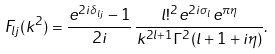<formula> <loc_0><loc_0><loc_500><loc_500>F _ { l j } ( k ^ { 2 } ) = \frac { e ^ { 2 i \delta _ { l j } } - 1 } { 2 i } \, \frac { l ! ^ { 2 } e ^ { 2 i \sigma _ { l } } e ^ { \pi \eta } } { k ^ { 2 l + 1 } \Gamma ^ { 2 } ( l + 1 + i \eta ) } .</formula> 